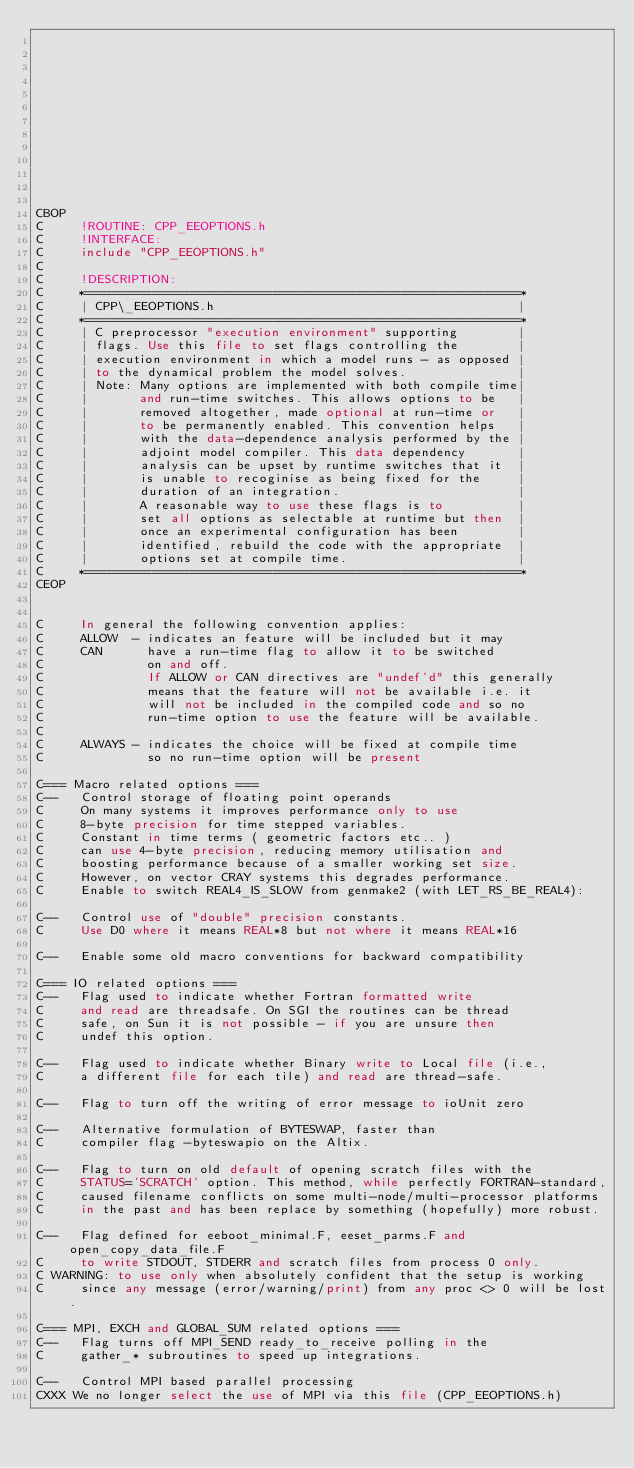<code> <loc_0><loc_0><loc_500><loc_500><_FORTRAN_>












CBOP
C     !ROUTINE: CPP_EEOPTIONS.h
C     !INTERFACE:
C     include "CPP_EEOPTIONS.h"
C
C     !DESCRIPTION:
C     *==========================================================*
C     | CPP\_EEOPTIONS.h                                         |
C     *==========================================================*
C     | C preprocessor "execution environment" supporting        |
C     | flags. Use this file to set flags controlling the        |
C     | execution environment in which a model runs - as opposed |
C     | to the dynamical problem the model solves.               |
C     | Note: Many options are implemented with both compile time|
C     |       and run-time switches. This allows options to be   |
C     |       removed altogether, made optional at run-time or   |
C     |       to be permanently enabled. This convention helps   |
C     |       with the data-dependence analysis performed by the |
C     |       adjoint model compiler. This data dependency       |
C     |       analysis can be upset by runtime switches that it  |
C     |       is unable to recoginise as being fixed for the     |
C     |       duration of an integration.                        |
C     |       A reasonable way to use these flags is to          |
C     |       set all options as selectable at runtime but then  |
C     |       once an experimental configuration has been        |
C     |       identified, rebuild the code with the appropriate  |
C     |       options set at compile time.                       |
C     *==========================================================*
CEOP


C     In general the following convention applies:
C     ALLOW  - indicates an feature will be included but it may
C     CAN      have a run-time flag to allow it to be switched
C              on and off.
C              If ALLOW or CAN directives are "undef'd" this generally
C              means that the feature will not be available i.e. it
C              will not be included in the compiled code and so no
C              run-time option to use the feature will be available.
C
C     ALWAYS - indicates the choice will be fixed at compile time
C              so no run-time option will be present

C=== Macro related options ===
C--   Control storage of floating point operands
C     On many systems it improves performance only to use
C     8-byte precision for time stepped variables.
C     Constant in time terms ( geometric factors etc.. )
C     can use 4-byte precision, reducing memory utilisation and
C     boosting performance because of a smaller working set size.
C     However, on vector CRAY systems this degrades performance.
C     Enable to switch REAL4_IS_SLOW from genmake2 (with LET_RS_BE_REAL4):

C--   Control use of "double" precision constants.
C     Use D0 where it means REAL*8 but not where it means REAL*16

C--   Enable some old macro conventions for backward compatibility

C=== IO related options ===
C--   Flag used to indicate whether Fortran formatted write
C     and read are threadsafe. On SGI the routines can be thread
C     safe, on Sun it is not possible - if you are unsure then
C     undef this option.

C--   Flag used to indicate whether Binary write to Local file (i.e.,
C     a different file for each tile) and read are thread-safe.

C--   Flag to turn off the writing of error message to ioUnit zero

C--   Alternative formulation of BYTESWAP, faster than
C     compiler flag -byteswapio on the Altix.

C--   Flag to turn on old default of opening scratch files with the
C     STATUS='SCRATCH' option. This method, while perfectly FORTRAN-standard,
C     caused filename conflicts on some multi-node/multi-processor platforms
C     in the past and has been replace by something (hopefully) more robust.

C--   Flag defined for eeboot_minimal.F, eeset_parms.F and open_copy_data_file.F
C     to write STDOUT, STDERR and scratch files from process 0 only.
C WARNING: to use only when absolutely confident that the setup is working
C     since any message (error/warning/print) from any proc <> 0 will be lost.

C=== MPI, EXCH and GLOBAL_SUM related options ===
C--   Flag turns off MPI_SEND ready_to_receive polling in the
C     gather_* subroutines to speed up integrations.

C--   Control MPI based parallel processing
CXXX We no longer select the use of MPI via this file (CPP_EEOPTIONS.h)</code> 